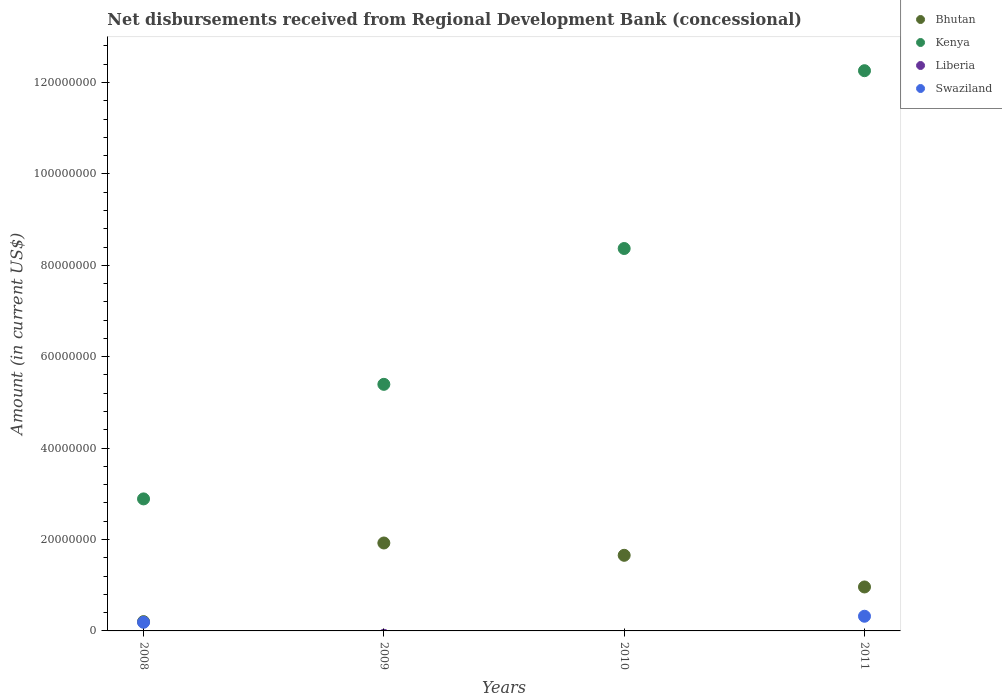How many different coloured dotlines are there?
Keep it short and to the point. 3. What is the amount of disbursements received from Regional Development Bank in Swaziland in 2008?
Make the answer very short. 1.89e+06. Across all years, what is the maximum amount of disbursements received from Regional Development Bank in Kenya?
Provide a short and direct response. 1.23e+08. Across all years, what is the minimum amount of disbursements received from Regional Development Bank in Kenya?
Your answer should be compact. 2.89e+07. In which year was the amount of disbursements received from Regional Development Bank in Kenya maximum?
Keep it short and to the point. 2011. What is the total amount of disbursements received from Regional Development Bank in Liberia in the graph?
Offer a terse response. 0. What is the difference between the amount of disbursements received from Regional Development Bank in Bhutan in 2008 and that in 2009?
Make the answer very short. -1.72e+07. What is the difference between the amount of disbursements received from Regional Development Bank in Kenya in 2009 and the amount of disbursements received from Regional Development Bank in Bhutan in 2008?
Your answer should be compact. 5.19e+07. What is the average amount of disbursements received from Regional Development Bank in Bhutan per year?
Give a very brief answer. 1.19e+07. In the year 2008, what is the difference between the amount of disbursements received from Regional Development Bank in Kenya and amount of disbursements received from Regional Development Bank in Swaziland?
Give a very brief answer. 2.70e+07. In how many years, is the amount of disbursements received from Regional Development Bank in Kenya greater than 100000000 US$?
Your answer should be compact. 1. What is the ratio of the amount of disbursements received from Regional Development Bank in Bhutan in 2008 to that in 2011?
Give a very brief answer. 0.21. Is the amount of disbursements received from Regional Development Bank in Bhutan in 2008 less than that in 2009?
Your response must be concise. Yes. What is the difference between the highest and the second highest amount of disbursements received from Regional Development Bank in Kenya?
Provide a short and direct response. 3.89e+07. What is the difference between the highest and the lowest amount of disbursements received from Regional Development Bank in Kenya?
Offer a terse response. 9.37e+07. In how many years, is the amount of disbursements received from Regional Development Bank in Bhutan greater than the average amount of disbursements received from Regional Development Bank in Bhutan taken over all years?
Give a very brief answer. 2. Is it the case that in every year, the sum of the amount of disbursements received from Regional Development Bank in Liberia and amount of disbursements received from Regional Development Bank in Kenya  is greater than the sum of amount of disbursements received from Regional Development Bank in Bhutan and amount of disbursements received from Regional Development Bank in Swaziland?
Provide a short and direct response. Yes. Is it the case that in every year, the sum of the amount of disbursements received from Regional Development Bank in Liberia and amount of disbursements received from Regional Development Bank in Bhutan  is greater than the amount of disbursements received from Regional Development Bank in Kenya?
Give a very brief answer. No. Does the amount of disbursements received from Regional Development Bank in Swaziland monotonically increase over the years?
Give a very brief answer. No. Is the amount of disbursements received from Regional Development Bank in Swaziland strictly less than the amount of disbursements received from Regional Development Bank in Kenya over the years?
Keep it short and to the point. Yes. How many dotlines are there?
Keep it short and to the point. 3. What is the difference between two consecutive major ticks on the Y-axis?
Your answer should be compact. 2.00e+07. Are the values on the major ticks of Y-axis written in scientific E-notation?
Make the answer very short. No. Does the graph contain any zero values?
Your answer should be compact. Yes. Where does the legend appear in the graph?
Your response must be concise. Top right. How many legend labels are there?
Keep it short and to the point. 4. What is the title of the graph?
Keep it short and to the point. Net disbursements received from Regional Development Bank (concessional). What is the Amount (in current US$) in Bhutan in 2008?
Provide a short and direct response. 2.03e+06. What is the Amount (in current US$) in Kenya in 2008?
Ensure brevity in your answer.  2.89e+07. What is the Amount (in current US$) of Swaziland in 2008?
Offer a very short reply. 1.89e+06. What is the Amount (in current US$) of Bhutan in 2009?
Your response must be concise. 1.92e+07. What is the Amount (in current US$) of Kenya in 2009?
Provide a succinct answer. 5.40e+07. What is the Amount (in current US$) of Bhutan in 2010?
Give a very brief answer. 1.65e+07. What is the Amount (in current US$) in Kenya in 2010?
Your response must be concise. 8.37e+07. What is the Amount (in current US$) in Liberia in 2010?
Your answer should be very brief. 0. What is the Amount (in current US$) in Swaziland in 2010?
Offer a terse response. 0. What is the Amount (in current US$) of Bhutan in 2011?
Keep it short and to the point. 9.62e+06. What is the Amount (in current US$) of Kenya in 2011?
Offer a very short reply. 1.23e+08. What is the Amount (in current US$) in Swaziland in 2011?
Keep it short and to the point. 3.21e+06. Across all years, what is the maximum Amount (in current US$) of Bhutan?
Provide a short and direct response. 1.92e+07. Across all years, what is the maximum Amount (in current US$) in Kenya?
Ensure brevity in your answer.  1.23e+08. Across all years, what is the maximum Amount (in current US$) of Swaziland?
Offer a terse response. 3.21e+06. Across all years, what is the minimum Amount (in current US$) in Bhutan?
Offer a terse response. 2.03e+06. Across all years, what is the minimum Amount (in current US$) of Kenya?
Your response must be concise. 2.89e+07. What is the total Amount (in current US$) in Bhutan in the graph?
Keep it short and to the point. 4.74e+07. What is the total Amount (in current US$) in Kenya in the graph?
Make the answer very short. 2.89e+08. What is the total Amount (in current US$) of Swaziland in the graph?
Provide a short and direct response. 5.10e+06. What is the difference between the Amount (in current US$) of Bhutan in 2008 and that in 2009?
Provide a succinct answer. -1.72e+07. What is the difference between the Amount (in current US$) in Kenya in 2008 and that in 2009?
Your answer should be very brief. -2.51e+07. What is the difference between the Amount (in current US$) in Bhutan in 2008 and that in 2010?
Offer a very short reply. -1.45e+07. What is the difference between the Amount (in current US$) of Kenya in 2008 and that in 2010?
Your response must be concise. -5.48e+07. What is the difference between the Amount (in current US$) of Bhutan in 2008 and that in 2011?
Your answer should be very brief. -7.59e+06. What is the difference between the Amount (in current US$) of Kenya in 2008 and that in 2011?
Offer a very short reply. -9.37e+07. What is the difference between the Amount (in current US$) of Swaziland in 2008 and that in 2011?
Your answer should be very brief. -1.32e+06. What is the difference between the Amount (in current US$) in Bhutan in 2009 and that in 2010?
Keep it short and to the point. 2.69e+06. What is the difference between the Amount (in current US$) in Kenya in 2009 and that in 2010?
Your response must be concise. -2.97e+07. What is the difference between the Amount (in current US$) in Bhutan in 2009 and that in 2011?
Give a very brief answer. 9.62e+06. What is the difference between the Amount (in current US$) of Kenya in 2009 and that in 2011?
Your response must be concise. -6.86e+07. What is the difference between the Amount (in current US$) of Bhutan in 2010 and that in 2011?
Your response must be concise. 6.92e+06. What is the difference between the Amount (in current US$) in Kenya in 2010 and that in 2011?
Offer a terse response. -3.89e+07. What is the difference between the Amount (in current US$) of Bhutan in 2008 and the Amount (in current US$) of Kenya in 2009?
Ensure brevity in your answer.  -5.19e+07. What is the difference between the Amount (in current US$) of Bhutan in 2008 and the Amount (in current US$) of Kenya in 2010?
Make the answer very short. -8.16e+07. What is the difference between the Amount (in current US$) of Bhutan in 2008 and the Amount (in current US$) of Kenya in 2011?
Make the answer very short. -1.21e+08. What is the difference between the Amount (in current US$) of Bhutan in 2008 and the Amount (in current US$) of Swaziland in 2011?
Your answer should be very brief. -1.18e+06. What is the difference between the Amount (in current US$) in Kenya in 2008 and the Amount (in current US$) in Swaziland in 2011?
Keep it short and to the point. 2.57e+07. What is the difference between the Amount (in current US$) in Bhutan in 2009 and the Amount (in current US$) in Kenya in 2010?
Keep it short and to the point. -6.44e+07. What is the difference between the Amount (in current US$) in Bhutan in 2009 and the Amount (in current US$) in Kenya in 2011?
Your answer should be very brief. -1.03e+08. What is the difference between the Amount (in current US$) in Bhutan in 2009 and the Amount (in current US$) in Swaziland in 2011?
Offer a terse response. 1.60e+07. What is the difference between the Amount (in current US$) in Kenya in 2009 and the Amount (in current US$) in Swaziland in 2011?
Give a very brief answer. 5.07e+07. What is the difference between the Amount (in current US$) in Bhutan in 2010 and the Amount (in current US$) in Kenya in 2011?
Offer a terse response. -1.06e+08. What is the difference between the Amount (in current US$) of Bhutan in 2010 and the Amount (in current US$) of Swaziland in 2011?
Give a very brief answer. 1.33e+07. What is the difference between the Amount (in current US$) in Kenya in 2010 and the Amount (in current US$) in Swaziland in 2011?
Provide a short and direct response. 8.05e+07. What is the average Amount (in current US$) in Bhutan per year?
Your response must be concise. 1.19e+07. What is the average Amount (in current US$) of Kenya per year?
Ensure brevity in your answer.  7.23e+07. What is the average Amount (in current US$) in Liberia per year?
Your response must be concise. 0. What is the average Amount (in current US$) in Swaziland per year?
Your answer should be compact. 1.28e+06. In the year 2008, what is the difference between the Amount (in current US$) in Bhutan and Amount (in current US$) in Kenya?
Offer a very short reply. -2.69e+07. In the year 2008, what is the difference between the Amount (in current US$) in Bhutan and Amount (in current US$) in Swaziland?
Ensure brevity in your answer.  1.45e+05. In the year 2008, what is the difference between the Amount (in current US$) of Kenya and Amount (in current US$) of Swaziland?
Your answer should be very brief. 2.70e+07. In the year 2009, what is the difference between the Amount (in current US$) of Bhutan and Amount (in current US$) of Kenya?
Offer a terse response. -3.47e+07. In the year 2010, what is the difference between the Amount (in current US$) of Bhutan and Amount (in current US$) of Kenya?
Your answer should be compact. -6.71e+07. In the year 2011, what is the difference between the Amount (in current US$) in Bhutan and Amount (in current US$) in Kenya?
Offer a terse response. -1.13e+08. In the year 2011, what is the difference between the Amount (in current US$) in Bhutan and Amount (in current US$) in Swaziland?
Your answer should be very brief. 6.41e+06. In the year 2011, what is the difference between the Amount (in current US$) of Kenya and Amount (in current US$) of Swaziland?
Provide a succinct answer. 1.19e+08. What is the ratio of the Amount (in current US$) of Bhutan in 2008 to that in 2009?
Your response must be concise. 0.11. What is the ratio of the Amount (in current US$) in Kenya in 2008 to that in 2009?
Your answer should be compact. 0.54. What is the ratio of the Amount (in current US$) in Bhutan in 2008 to that in 2010?
Your answer should be compact. 0.12. What is the ratio of the Amount (in current US$) of Kenya in 2008 to that in 2010?
Offer a terse response. 0.35. What is the ratio of the Amount (in current US$) of Bhutan in 2008 to that in 2011?
Ensure brevity in your answer.  0.21. What is the ratio of the Amount (in current US$) of Kenya in 2008 to that in 2011?
Offer a very short reply. 0.24. What is the ratio of the Amount (in current US$) of Swaziland in 2008 to that in 2011?
Provide a succinct answer. 0.59. What is the ratio of the Amount (in current US$) of Bhutan in 2009 to that in 2010?
Give a very brief answer. 1.16. What is the ratio of the Amount (in current US$) in Kenya in 2009 to that in 2010?
Ensure brevity in your answer.  0.64. What is the ratio of the Amount (in current US$) of Bhutan in 2009 to that in 2011?
Offer a terse response. 2. What is the ratio of the Amount (in current US$) in Kenya in 2009 to that in 2011?
Keep it short and to the point. 0.44. What is the ratio of the Amount (in current US$) in Bhutan in 2010 to that in 2011?
Your answer should be compact. 1.72. What is the ratio of the Amount (in current US$) in Kenya in 2010 to that in 2011?
Your answer should be compact. 0.68. What is the difference between the highest and the second highest Amount (in current US$) in Bhutan?
Offer a terse response. 2.69e+06. What is the difference between the highest and the second highest Amount (in current US$) in Kenya?
Offer a very short reply. 3.89e+07. What is the difference between the highest and the lowest Amount (in current US$) in Bhutan?
Give a very brief answer. 1.72e+07. What is the difference between the highest and the lowest Amount (in current US$) of Kenya?
Provide a short and direct response. 9.37e+07. What is the difference between the highest and the lowest Amount (in current US$) in Swaziland?
Your response must be concise. 3.21e+06. 